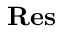<formula> <loc_0><loc_0><loc_500><loc_500>R e s</formula> 